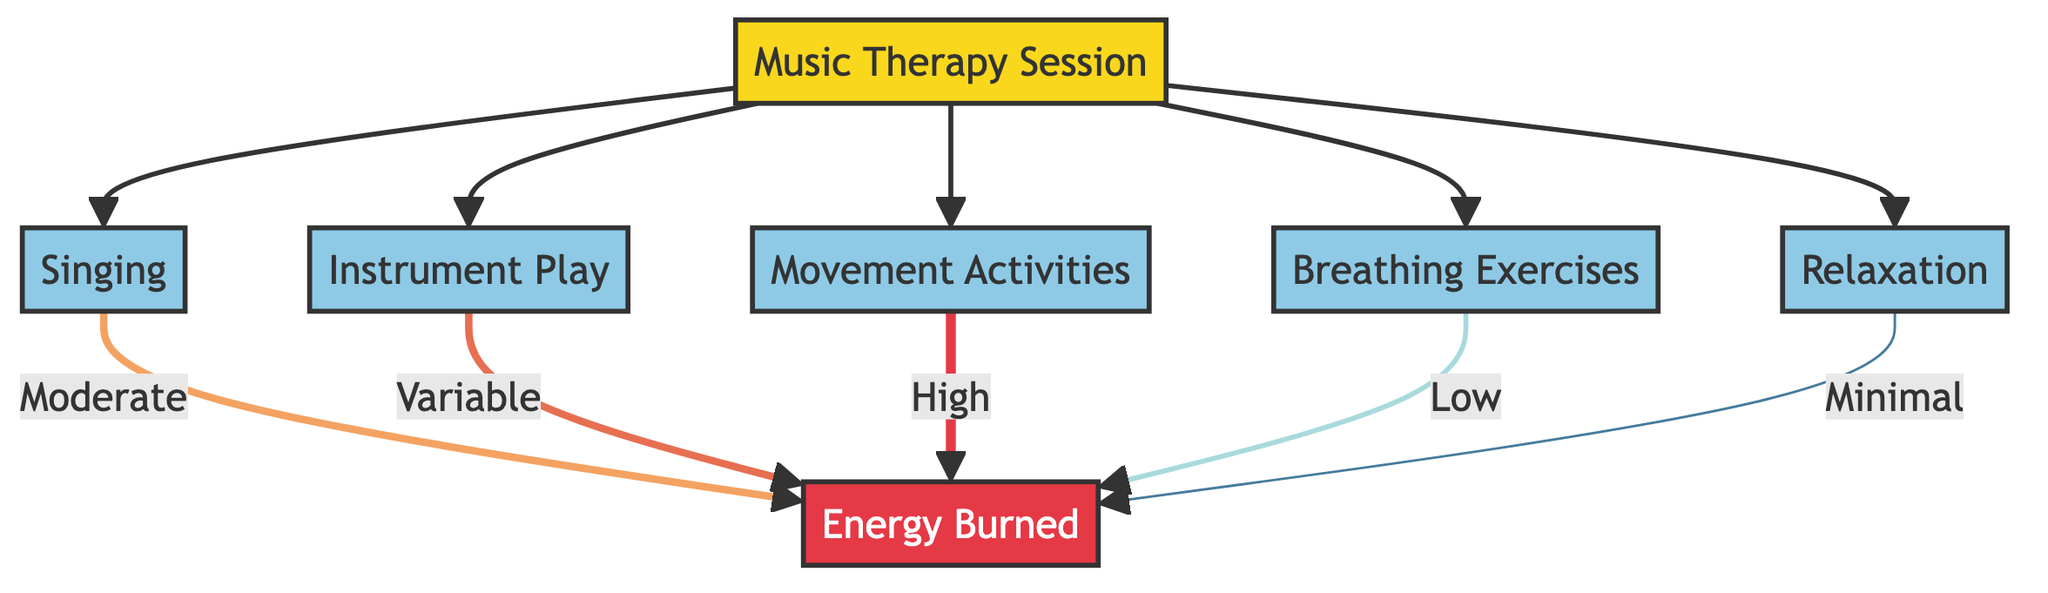What activities are included in the Music Therapy Session? The diagram displays five activities branching off from the Music Therapy Session node: Singing, Instrument Play, Movement Activities, Breathing Exercises, and Relaxation. These are directly connected to the Music Therapy Session.
Answer: Singing, Instrument Play, Movement Activities, Breathing Exercises, Relaxation Which activity has the highest energy expenditure? The diagram indicates that Movement Activities leads to the highest energy expenditure, labeled as High in the flow. Therefore, combining the information that Movement Activities connects to Energy Burned and shows a label of High confirms its position as the highest.
Answer: High What is the energy expenditure for Breathing Exercises? In the diagram, Breathing Exercises leads to a Low energy expenditure. The label directly indicating Low evidences that this specific activity exerts minimal physical energy compared to others.
Answer: Low How many activities contribute to energy expenditure in the Music Therapy Session? There are five distinct activities listed: Singing, Instrument Play, Movement Activities, Breathing Exercises, and Relaxation. Each of these activities contributes different levels of energy expenditure, confirming that all five are included in the total count.
Answer: Five What is the relationship between Singing and Energy Burned? The diagram assigns a Moderate energy expenditure label to the connection from Singing to Energy Burned. This follows the flow of the diagram, showing the direct line from Singing to Energy Burned marked with Moderate.
Answer: Moderate What is the energy expenditure level for Relaxation? The flowchart indicates that Relaxation contributes a Minimal energy expenditure. This can be directly observed in the diagram where Relaxation links to Energy Burned with the label Minimal.
Answer: Minimal Which activity has a variable energy expenditure? According to the diagram, Instrument Play is the activity linked to Energy Burned under the Variable label. The direct connection from Instrument Play leads to Energy Burned with Variable identifies it specifically as a fluctuating expenditure.
Answer: Variable What type of energy expenditure is associated with the Relaxation activity? The diagram conveys that Relaxation leads to Minimal energy expenditure. This is noted in the connection to Energy Burned that is labeled accordingly, highlighting that it requires the least amount of energy.
Answer: Minimal 